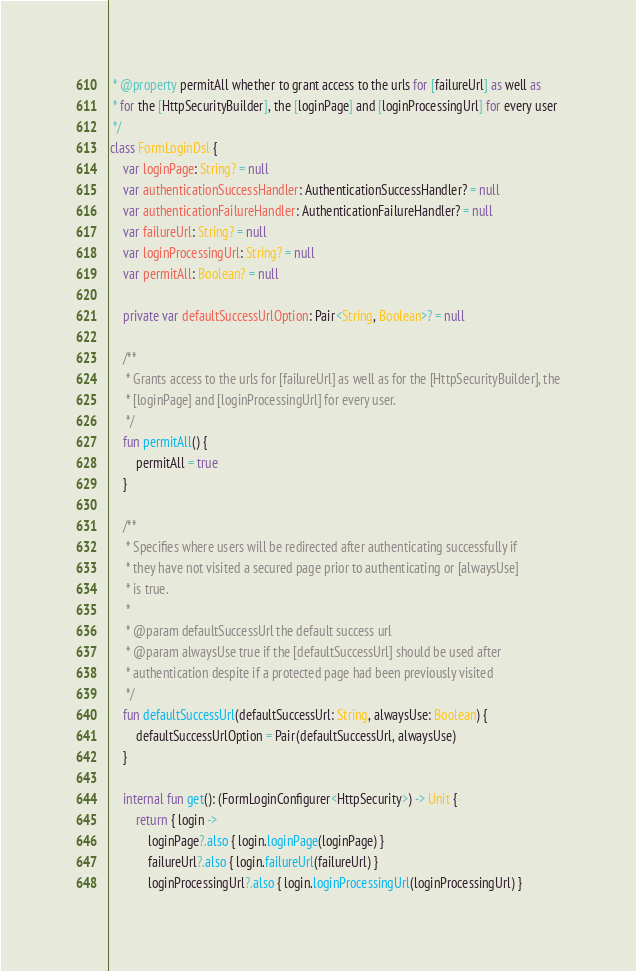Convert code to text. <code><loc_0><loc_0><loc_500><loc_500><_Kotlin_> * @property permitAll whether to grant access to the urls for [failureUrl] as well as
 * for the [HttpSecurityBuilder], the [loginPage] and [loginProcessingUrl] for every user
 */
class FormLoginDsl {
    var loginPage: String? = null
    var authenticationSuccessHandler: AuthenticationSuccessHandler? = null
    var authenticationFailureHandler: AuthenticationFailureHandler? = null
    var failureUrl: String? = null
    var loginProcessingUrl: String? = null
    var permitAll: Boolean? = null

    private var defaultSuccessUrlOption: Pair<String, Boolean>? = null

    /**
     * Grants access to the urls for [failureUrl] as well as for the [HttpSecurityBuilder], the
     * [loginPage] and [loginProcessingUrl] for every user.
     */
    fun permitAll() {
        permitAll = true
    }

    /**
     * Specifies where users will be redirected after authenticating successfully if
     * they have not visited a secured page prior to authenticating or [alwaysUse]
     * is true.
     *
     * @param defaultSuccessUrl the default success url
     * @param alwaysUse true if the [defaultSuccessUrl] should be used after
     * authentication despite if a protected page had been previously visited
     */
    fun defaultSuccessUrl(defaultSuccessUrl: String, alwaysUse: Boolean) {
        defaultSuccessUrlOption = Pair(defaultSuccessUrl, alwaysUse)
    }

    internal fun get(): (FormLoginConfigurer<HttpSecurity>) -> Unit {
        return { login ->
            loginPage?.also { login.loginPage(loginPage) }
            failureUrl?.also { login.failureUrl(failureUrl) }
            loginProcessingUrl?.also { login.loginProcessingUrl(loginProcessingUrl) }</code> 